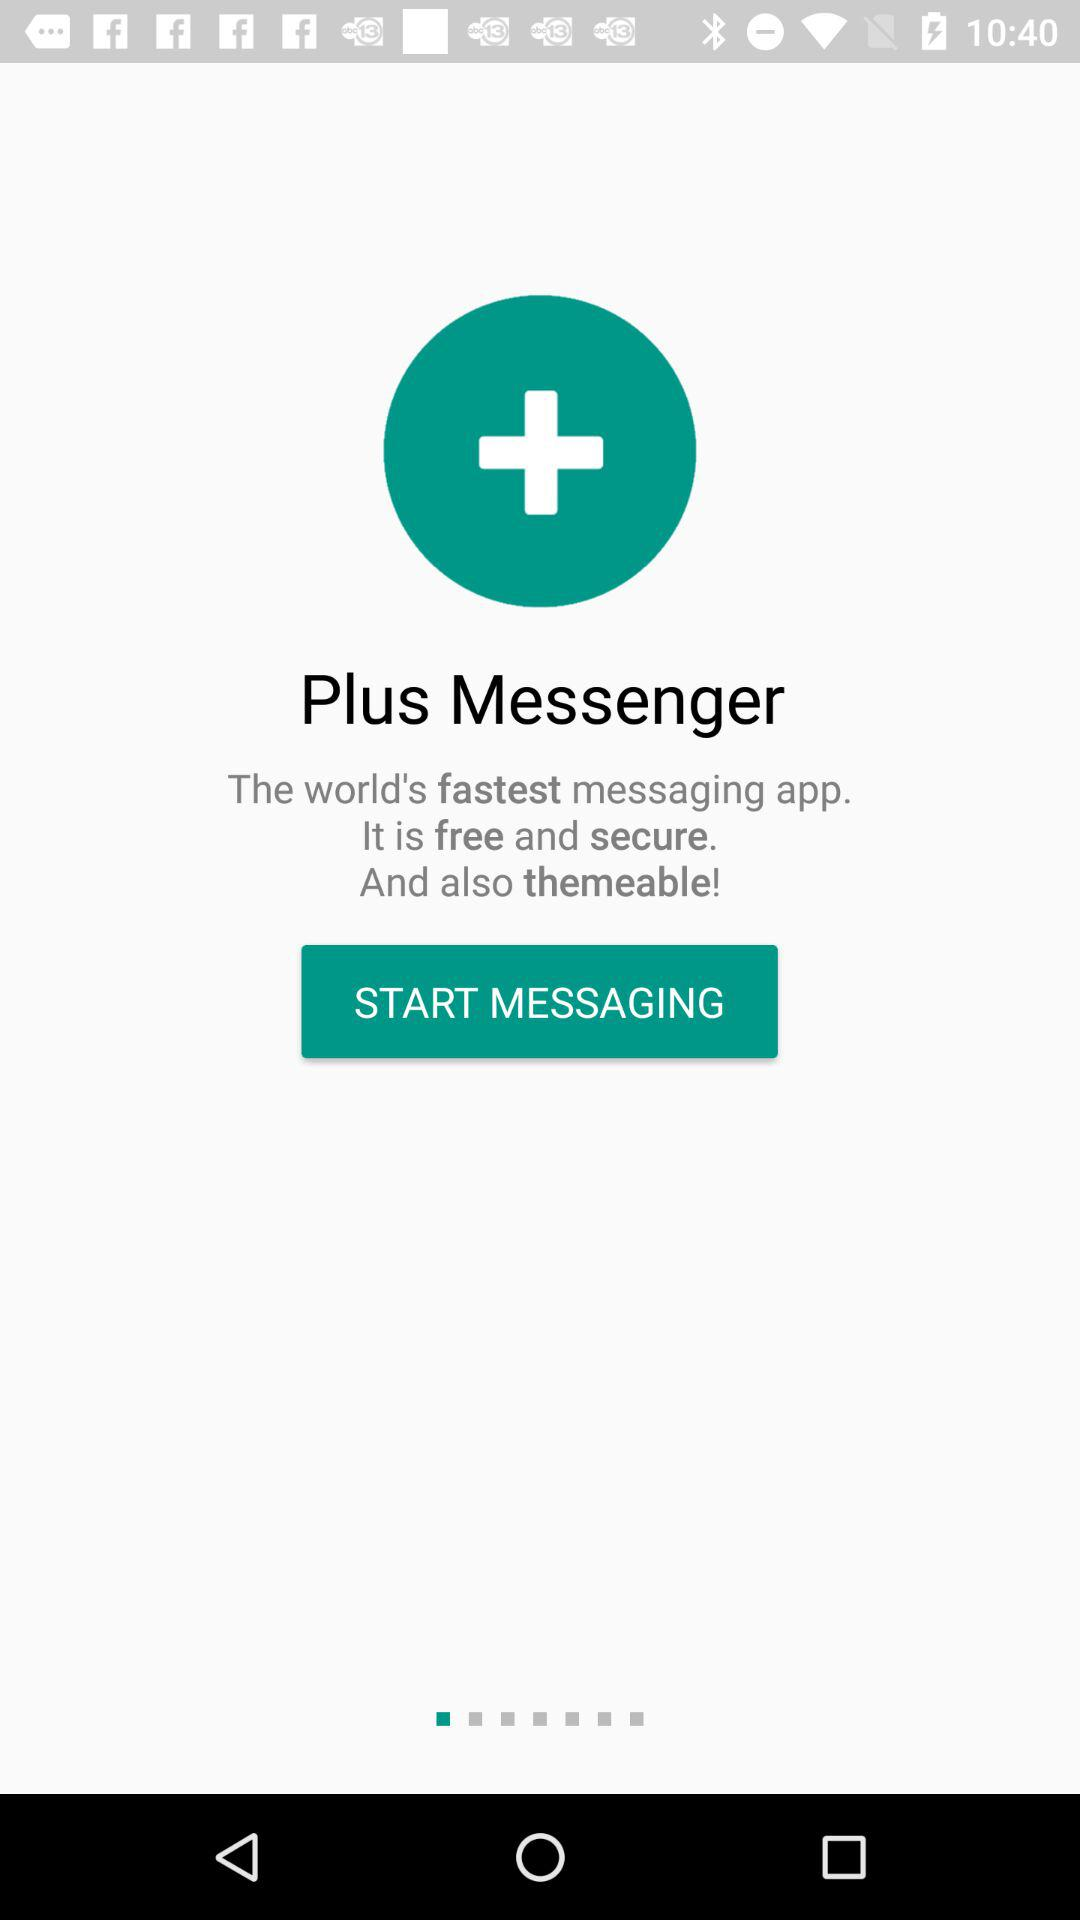Is the app free or paid?
Answer the question using a single word or phrase. It is free. 